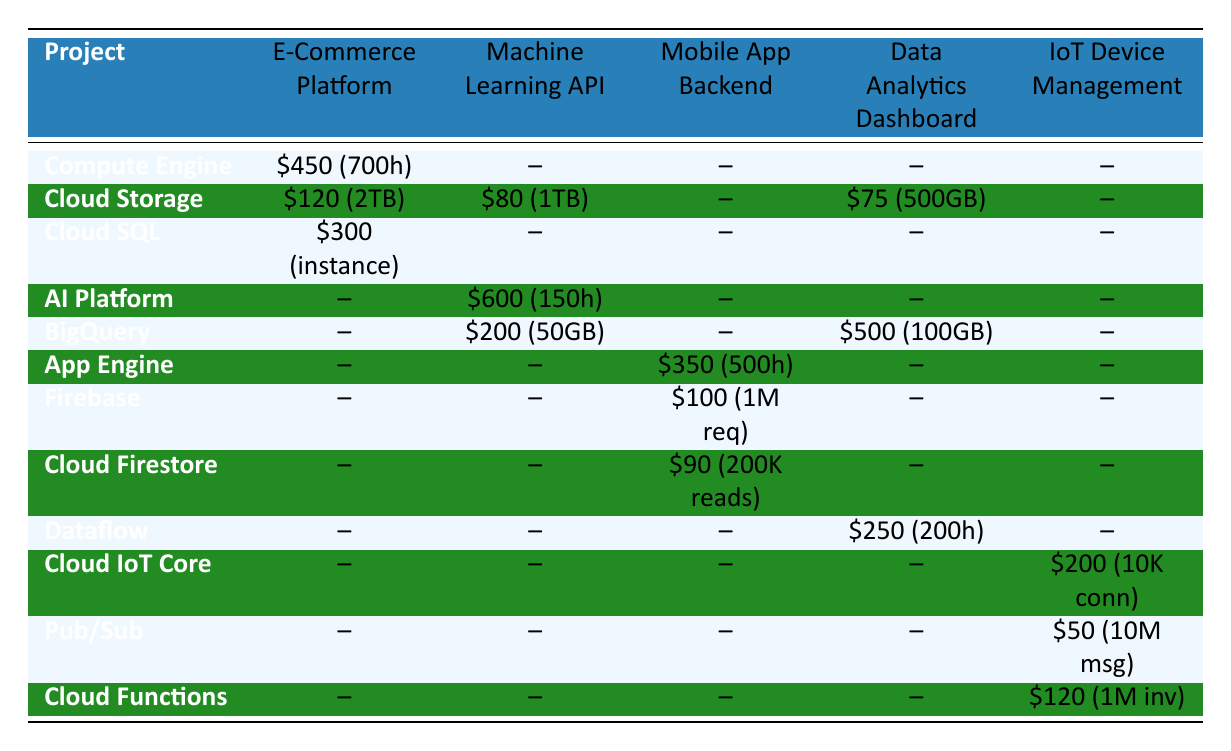What is the total cost of services used in the E-Commerce Platform project? To find the total cost for the E-Commerce Platform, sum up the costs of all its services: Compute Engine ($450) + Cloud Storage ($120) + Cloud SQL ($300) = $450 + $120 + $300 = $870.
Answer: 870 Which project has the highest service cost for Cloud Storage? Looking at the Cloud Storage costs, E-Commerce Platform has $120, Machine Learning API has $80, Data Analytics Dashboard has $75, and IoT Device Management has none. Hence, E-Commerce Platform has the highest cost for Cloud Storage at $120.
Answer: E-Commerce Platform Is there any project that does not use Cloud Functions? To determine this, check which projects have an entry under Cloud Functions. The E-Commerce Platform, Machine Learning API, and Mobile Application Backend do not have Cloud Functions listed. Therefore, they do not use Cloud Functions.
Answer: Yes What service had the highest usage in the Machine Learning API project? The services in the Machine Learning API are: AI Platform (150 training hours), Cloud Storage (1TB), and BigQuery (50 GB processed). The AI Platform service has the highest usage specified in training hours (150 hours).
Answer: AI Platform What is the average cost of all services used in the IoT Device Management project? The services for IoT Device Management are Cloud IoT Core ($200), Pub/Sub ($50), and Cloud Functions ($120). First, find the total cost: $200 + $50 + $120 = $370. Then, divide by the number of services (3): $370/3 ≈ $123.33.
Answer: 123.33 In which region is the Cloud SQL service hosted? The Cloud SQL service is listed under the E-Commerce Platform, which is in the region us-central1 according to the table.
Answer: us-central1 Which project uses the most resources in terms of combined service costs? Calculate the total costs for each project: E-Commerce Platform: $870, Machine Learning API: $880, Mobile Application Backend: $540, Data Analytics Dashboard: $825, IoT Device Management: $370. The highest total cost is Machine Learning API at $880.
Answer: Machine Learning API Does the Data Analytics Dashboard project use Cloud Storage more than any other project? For Cloud Storage, E-Commerce Platform has $120, Machine Learning API has $80, Data Analytics Dashboard has $75, and IoT Device Management has none. The Data Analytics Dashboard has less than E-Commerce Platform and Machine Learning API, so it does not use Cloud Storage more than any other project.
Answer: No What is the difference in cost between the highest and lowest services in the Mobile Application Backend? The services in Mobile Application Backend have costs: App Engine ($350), Firebase ($100), and Cloud Firestore ($90). The highest is App Engine ($350) and the lowest is Cloud Firestore ($90). The difference is $350 - $90 = $260.
Answer: 260 